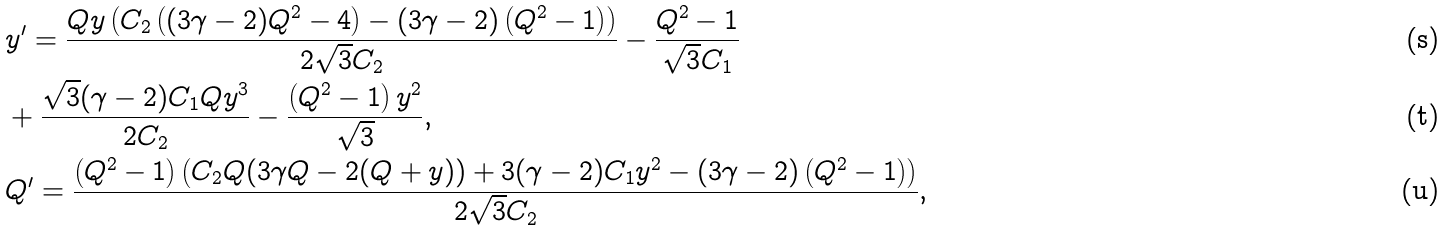<formula> <loc_0><loc_0><loc_500><loc_500>& y ^ { \prime } = \frac { Q y \left ( C _ { 2 } \left ( ( 3 \gamma - 2 ) Q ^ { 2 } - 4 \right ) - ( 3 \gamma - 2 ) \left ( Q ^ { 2 } - 1 \right ) \right ) } { 2 \sqrt { 3 } C _ { 2 } } - \frac { Q ^ { 2 } - 1 } { \sqrt { 3 } C _ { 1 } } \\ & + \frac { \sqrt { 3 } ( \gamma - 2 ) C _ { 1 } Q y ^ { 3 } } { 2 C _ { 2 } } - \frac { \left ( Q ^ { 2 } - 1 \right ) y ^ { 2 } } { \sqrt { 3 } } , \\ & Q ^ { \prime } = \frac { \left ( Q ^ { 2 } - 1 \right ) \left ( C _ { 2 } Q ( 3 \gamma Q - 2 ( Q + y ) ) + 3 ( \gamma - 2 ) C _ { 1 } y ^ { 2 } - ( 3 \gamma - 2 ) \left ( Q ^ { 2 } - 1 \right ) \right ) } { 2 \sqrt { 3 } C _ { 2 } } ,</formula> 